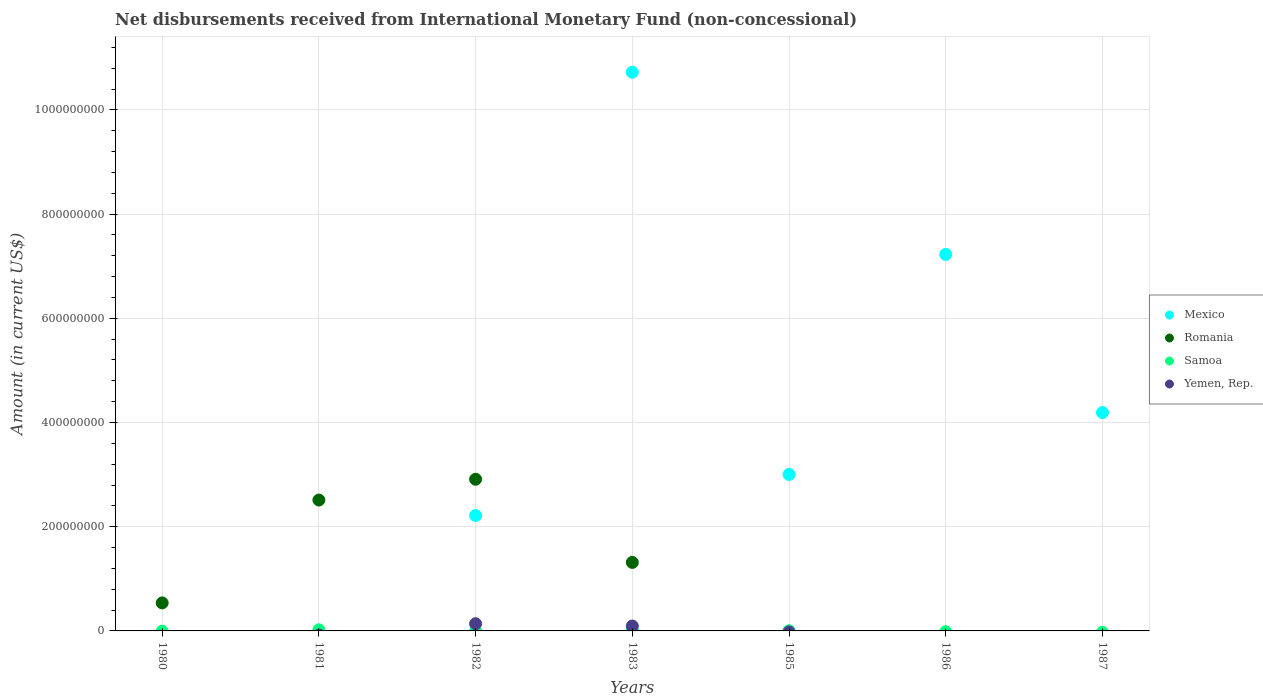Across all years, what is the maximum amount of disbursements received from International Monetary Fund in Romania?
Offer a very short reply. 2.91e+08. Across all years, what is the minimum amount of disbursements received from International Monetary Fund in Romania?
Keep it short and to the point. 0. In which year was the amount of disbursements received from International Monetary Fund in Mexico maximum?
Keep it short and to the point. 1983. What is the total amount of disbursements received from International Monetary Fund in Samoa in the graph?
Your response must be concise. 4.52e+06. What is the difference between the amount of disbursements received from International Monetary Fund in Mexico in 1983 and that in 1985?
Your response must be concise. 7.72e+08. What is the difference between the amount of disbursements received from International Monetary Fund in Samoa in 1980 and the amount of disbursements received from International Monetary Fund in Romania in 1982?
Ensure brevity in your answer.  -2.91e+08. What is the average amount of disbursements received from International Monetary Fund in Mexico per year?
Keep it short and to the point. 3.91e+08. In the year 1982, what is the difference between the amount of disbursements received from International Monetary Fund in Mexico and amount of disbursements received from International Monetary Fund in Romania?
Ensure brevity in your answer.  -6.96e+07. In how many years, is the amount of disbursements received from International Monetary Fund in Mexico greater than 920000000 US$?
Offer a terse response. 1. What is the ratio of the amount of disbursements received from International Monetary Fund in Mexico in 1982 to that in 1985?
Provide a succinct answer. 0.74. Is the amount of disbursements received from International Monetary Fund in Mexico in 1983 less than that in 1986?
Ensure brevity in your answer.  No. What is the difference between the highest and the second highest amount of disbursements received from International Monetary Fund in Romania?
Keep it short and to the point. 3.99e+07. What is the difference between the highest and the lowest amount of disbursements received from International Monetary Fund in Romania?
Keep it short and to the point. 2.91e+08. Does the amount of disbursements received from International Monetary Fund in Yemen, Rep. monotonically increase over the years?
Give a very brief answer. No. Is the amount of disbursements received from International Monetary Fund in Mexico strictly greater than the amount of disbursements received from International Monetary Fund in Romania over the years?
Your answer should be very brief. No. Is the amount of disbursements received from International Monetary Fund in Mexico strictly less than the amount of disbursements received from International Monetary Fund in Yemen, Rep. over the years?
Offer a terse response. No. How many dotlines are there?
Keep it short and to the point. 4. Are the values on the major ticks of Y-axis written in scientific E-notation?
Make the answer very short. No. Does the graph contain any zero values?
Offer a very short reply. Yes. Does the graph contain grids?
Your answer should be very brief. Yes. What is the title of the graph?
Give a very brief answer. Net disbursements received from International Monetary Fund (non-concessional). What is the label or title of the Y-axis?
Your answer should be compact. Amount (in current US$). What is the Amount (in current US$) in Mexico in 1980?
Provide a short and direct response. 0. What is the Amount (in current US$) of Romania in 1980?
Keep it short and to the point. 5.38e+07. What is the Amount (in current US$) in Samoa in 1980?
Give a very brief answer. 0. What is the Amount (in current US$) of Yemen, Rep. in 1980?
Provide a short and direct response. 0. What is the Amount (in current US$) of Mexico in 1981?
Ensure brevity in your answer.  0. What is the Amount (in current US$) in Romania in 1981?
Provide a succinct answer. 2.51e+08. What is the Amount (in current US$) of Samoa in 1981?
Offer a very short reply. 2.20e+06. What is the Amount (in current US$) of Mexico in 1982?
Ensure brevity in your answer.  2.22e+08. What is the Amount (in current US$) in Romania in 1982?
Offer a terse response. 2.91e+08. What is the Amount (in current US$) of Yemen, Rep. in 1982?
Your answer should be very brief. 1.38e+07. What is the Amount (in current US$) of Mexico in 1983?
Make the answer very short. 1.07e+09. What is the Amount (in current US$) in Romania in 1983?
Keep it short and to the point. 1.32e+08. What is the Amount (in current US$) in Samoa in 1983?
Provide a succinct answer. 2.00e+06. What is the Amount (in current US$) of Yemen, Rep. in 1983?
Ensure brevity in your answer.  9.40e+06. What is the Amount (in current US$) of Mexico in 1985?
Offer a very short reply. 3.00e+08. What is the Amount (in current US$) in Romania in 1985?
Your answer should be compact. 0. What is the Amount (in current US$) of Samoa in 1985?
Keep it short and to the point. 3.20e+05. What is the Amount (in current US$) in Mexico in 1986?
Give a very brief answer. 7.23e+08. What is the Amount (in current US$) in Yemen, Rep. in 1986?
Ensure brevity in your answer.  0. What is the Amount (in current US$) in Mexico in 1987?
Give a very brief answer. 4.19e+08. What is the Amount (in current US$) of Yemen, Rep. in 1987?
Provide a short and direct response. 0. Across all years, what is the maximum Amount (in current US$) in Mexico?
Provide a short and direct response. 1.07e+09. Across all years, what is the maximum Amount (in current US$) of Romania?
Ensure brevity in your answer.  2.91e+08. Across all years, what is the maximum Amount (in current US$) of Samoa?
Your answer should be compact. 2.20e+06. Across all years, what is the maximum Amount (in current US$) of Yemen, Rep.?
Ensure brevity in your answer.  1.38e+07. Across all years, what is the minimum Amount (in current US$) in Mexico?
Your answer should be very brief. 0. Across all years, what is the minimum Amount (in current US$) of Yemen, Rep.?
Keep it short and to the point. 0. What is the total Amount (in current US$) of Mexico in the graph?
Keep it short and to the point. 2.74e+09. What is the total Amount (in current US$) of Romania in the graph?
Your answer should be very brief. 7.28e+08. What is the total Amount (in current US$) in Samoa in the graph?
Provide a succinct answer. 4.52e+06. What is the total Amount (in current US$) of Yemen, Rep. in the graph?
Your answer should be compact. 2.32e+07. What is the difference between the Amount (in current US$) of Romania in 1980 and that in 1981?
Provide a succinct answer. -1.97e+08. What is the difference between the Amount (in current US$) in Romania in 1980 and that in 1982?
Your answer should be very brief. -2.37e+08. What is the difference between the Amount (in current US$) of Romania in 1980 and that in 1983?
Offer a very short reply. -7.77e+07. What is the difference between the Amount (in current US$) of Romania in 1981 and that in 1982?
Ensure brevity in your answer.  -3.99e+07. What is the difference between the Amount (in current US$) in Romania in 1981 and that in 1983?
Offer a very short reply. 1.20e+08. What is the difference between the Amount (in current US$) in Samoa in 1981 and that in 1983?
Offer a terse response. 2.00e+05. What is the difference between the Amount (in current US$) of Samoa in 1981 and that in 1985?
Make the answer very short. 1.88e+06. What is the difference between the Amount (in current US$) in Mexico in 1982 and that in 1983?
Ensure brevity in your answer.  -8.51e+08. What is the difference between the Amount (in current US$) of Romania in 1982 and that in 1983?
Your response must be concise. 1.60e+08. What is the difference between the Amount (in current US$) in Yemen, Rep. in 1982 and that in 1983?
Your answer should be very brief. 4.40e+06. What is the difference between the Amount (in current US$) of Mexico in 1982 and that in 1985?
Ensure brevity in your answer.  -7.88e+07. What is the difference between the Amount (in current US$) in Mexico in 1982 and that in 1986?
Keep it short and to the point. -5.01e+08. What is the difference between the Amount (in current US$) in Mexico in 1982 and that in 1987?
Your answer should be very brief. -1.98e+08. What is the difference between the Amount (in current US$) in Mexico in 1983 and that in 1985?
Make the answer very short. 7.72e+08. What is the difference between the Amount (in current US$) of Samoa in 1983 and that in 1985?
Your answer should be very brief. 1.68e+06. What is the difference between the Amount (in current US$) in Mexico in 1983 and that in 1986?
Your answer should be very brief. 3.50e+08. What is the difference between the Amount (in current US$) of Mexico in 1983 and that in 1987?
Offer a very short reply. 6.53e+08. What is the difference between the Amount (in current US$) in Mexico in 1985 and that in 1986?
Your answer should be compact. -4.22e+08. What is the difference between the Amount (in current US$) in Mexico in 1985 and that in 1987?
Provide a short and direct response. -1.19e+08. What is the difference between the Amount (in current US$) in Mexico in 1986 and that in 1987?
Your answer should be compact. 3.04e+08. What is the difference between the Amount (in current US$) in Romania in 1980 and the Amount (in current US$) in Samoa in 1981?
Ensure brevity in your answer.  5.16e+07. What is the difference between the Amount (in current US$) in Romania in 1980 and the Amount (in current US$) in Yemen, Rep. in 1982?
Make the answer very short. 4.00e+07. What is the difference between the Amount (in current US$) of Romania in 1980 and the Amount (in current US$) of Samoa in 1983?
Give a very brief answer. 5.18e+07. What is the difference between the Amount (in current US$) of Romania in 1980 and the Amount (in current US$) of Yemen, Rep. in 1983?
Ensure brevity in your answer.  4.44e+07. What is the difference between the Amount (in current US$) of Romania in 1980 and the Amount (in current US$) of Samoa in 1985?
Offer a terse response. 5.35e+07. What is the difference between the Amount (in current US$) of Romania in 1981 and the Amount (in current US$) of Yemen, Rep. in 1982?
Ensure brevity in your answer.  2.37e+08. What is the difference between the Amount (in current US$) in Samoa in 1981 and the Amount (in current US$) in Yemen, Rep. in 1982?
Your response must be concise. -1.16e+07. What is the difference between the Amount (in current US$) in Romania in 1981 and the Amount (in current US$) in Samoa in 1983?
Provide a succinct answer. 2.49e+08. What is the difference between the Amount (in current US$) in Romania in 1981 and the Amount (in current US$) in Yemen, Rep. in 1983?
Your answer should be compact. 2.42e+08. What is the difference between the Amount (in current US$) of Samoa in 1981 and the Amount (in current US$) of Yemen, Rep. in 1983?
Your answer should be compact. -7.20e+06. What is the difference between the Amount (in current US$) in Romania in 1981 and the Amount (in current US$) in Samoa in 1985?
Your response must be concise. 2.51e+08. What is the difference between the Amount (in current US$) in Mexico in 1982 and the Amount (in current US$) in Romania in 1983?
Offer a terse response. 9.00e+07. What is the difference between the Amount (in current US$) in Mexico in 1982 and the Amount (in current US$) in Samoa in 1983?
Make the answer very short. 2.20e+08. What is the difference between the Amount (in current US$) in Mexico in 1982 and the Amount (in current US$) in Yemen, Rep. in 1983?
Your answer should be compact. 2.12e+08. What is the difference between the Amount (in current US$) of Romania in 1982 and the Amount (in current US$) of Samoa in 1983?
Offer a terse response. 2.89e+08. What is the difference between the Amount (in current US$) of Romania in 1982 and the Amount (in current US$) of Yemen, Rep. in 1983?
Provide a succinct answer. 2.82e+08. What is the difference between the Amount (in current US$) in Mexico in 1982 and the Amount (in current US$) in Samoa in 1985?
Your response must be concise. 2.21e+08. What is the difference between the Amount (in current US$) of Romania in 1982 and the Amount (in current US$) of Samoa in 1985?
Offer a terse response. 2.91e+08. What is the difference between the Amount (in current US$) in Mexico in 1983 and the Amount (in current US$) in Samoa in 1985?
Ensure brevity in your answer.  1.07e+09. What is the difference between the Amount (in current US$) of Romania in 1983 and the Amount (in current US$) of Samoa in 1985?
Provide a short and direct response. 1.31e+08. What is the average Amount (in current US$) in Mexico per year?
Give a very brief answer. 3.91e+08. What is the average Amount (in current US$) of Romania per year?
Ensure brevity in your answer.  1.04e+08. What is the average Amount (in current US$) in Samoa per year?
Your answer should be very brief. 6.46e+05. What is the average Amount (in current US$) in Yemen, Rep. per year?
Keep it short and to the point. 3.31e+06. In the year 1981, what is the difference between the Amount (in current US$) of Romania and Amount (in current US$) of Samoa?
Your answer should be compact. 2.49e+08. In the year 1982, what is the difference between the Amount (in current US$) in Mexico and Amount (in current US$) in Romania?
Make the answer very short. -6.96e+07. In the year 1982, what is the difference between the Amount (in current US$) in Mexico and Amount (in current US$) in Yemen, Rep.?
Your answer should be very brief. 2.08e+08. In the year 1982, what is the difference between the Amount (in current US$) in Romania and Amount (in current US$) in Yemen, Rep.?
Your answer should be compact. 2.77e+08. In the year 1983, what is the difference between the Amount (in current US$) in Mexico and Amount (in current US$) in Romania?
Give a very brief answer. 9.41e+08. In the year 1983, what is the difference between the Amount (in current US$) of Mexico and Amount (in current US$) of Samoa?
Offer a very short reply. 1.07e+09. In the year 1983, what is the difference between the Amount (in current US$) of Mexico and Amount (in current US$) of Yemen, Rep.?
Make the answer very short. 1.06e+09. In the year 1983, what is the difference between the Amount (in current US$) of Romania and Amount (in current US$) of Samoa?
Make the answer very short. 1.30e+08. In the year 1983, what is the difference between the Amount (in current US$) in Romania and Amount (in current US$) in Yemen, Rep.?
Your answer should be very brief. 1.22e+08. In the year 1983, what is the difference between the Amount (in current US$) of Samoa and Amount (in current US$) of Yemen, Rep.?
Provide a short and direct response. -7.40e+06. In the year 1985, what is the difference between the Amount (in current US$) in Mexico and Amount (in current US$) in Samoa?
Your answer should be compact. 3.00e+08. What is the ratio of the Amount (in current US$) in Romania in 1980 to that in 1981?
Your answer should be very brief. 0.21. What is the ratio of the Amount (in current US$) of Romania in 1980 to that in 1982?
Offer a very short reply. 0.18. What is the ratio of the Amount (in current US$) in Romania in 1980 to that in 1983?
Provide a succinct answer. 0.41. What is the ratio of the Amount (in current US$) of Romania in 1981 to that in 1982?
Ensure brevity in your answer.  0.86. What is the ratio of the Amount (in current US$) of Romania in 1981 to that in 1983?
Provide a short and direct response. 1.91. What is the ratio of the Amount (in current US$) of Samoa in 1981 to that in 1985?
Offer a terse response. 6.88. What is the ratio of the Amount (in current US$) of Mexico in 1982 to that in 1983?
Your answer should be compact. 0.21. What is the ratio of the Amount (in current US$) in Romania in 1982 to that in 1983?
Offer a terse response. 2.21. What is the ratio of the Amount (in current US$) of Yemen, Rep. in 1982 to that in 1983?
Offer a very short reply. 1.47. What is the ratio of the Amount (in current US$) in Mexico in 1982 to that in 1985?
Provide a short and direct response. 0.74. What is the ratio of the Amount (in current US$) of Mexico in 1982 to that in 1986?
Your answer should be very brief. 0.31. What is the ratio of the Amount (in current US$) in Mexico in 1982 to that in 1987?
Your answer should be compact. 0.53. What is the ratio of the Amount (in current US$) in Mexico in 1983 to that in 1985?
Keep it short and to the point. 3.57. What is the ratio of the Amount (in current US$) of Samoa in 1983 to that in 1985?
Provide a succinct answer. 6.25. What is the ratio of the Amount (in current US$) in Mexico in 1983 to that in 1986?
Give a very brief answer. 1.48. What is the ratio of the Amount (in current US$) in Mexico in 1983 to that in 1987?
Provide a short and direct response. 2.56. What is the ratio of the Amount (in current US$) of Mexico in 1985 to that in 1986?
Offer a very short reply. 0.42. What is the ratio of the Amount (in current US$) in Mexico in 1985 to that in 1987?
Your answer should be very brief. 0.72. What is the ratio of the Amount (in current US$) in Mexico in 1986 to that in 1987?
Give a very brief answer. 1.72. What is the difference between the highest and the second highest Amount (in current US$) in Mexico?
Ensure brevity in your answer.  3.50e+08. What is the difference between the highest and the second highest Amount (in current US$) in Romania?
Offer a terse response. 3.99e+07. What is the difference between the highest and the lowest Amount (in current US$) of Mexico?
Make the answer very short. 1.07e+09. What is the difference between the highest and the lowest Amount (in current US$) of Romania?
Offer a very short reply. 2.91e+08. What is the difference between the highest and the lowest Amount (in current US$) of Samoa?
Provide a succinct answer. 2.20e+06. What is the difference between the highest and the lowest Amount (in current US$) of Yemen, Rep.?
Give a very brief answer. 1.38e+07. 